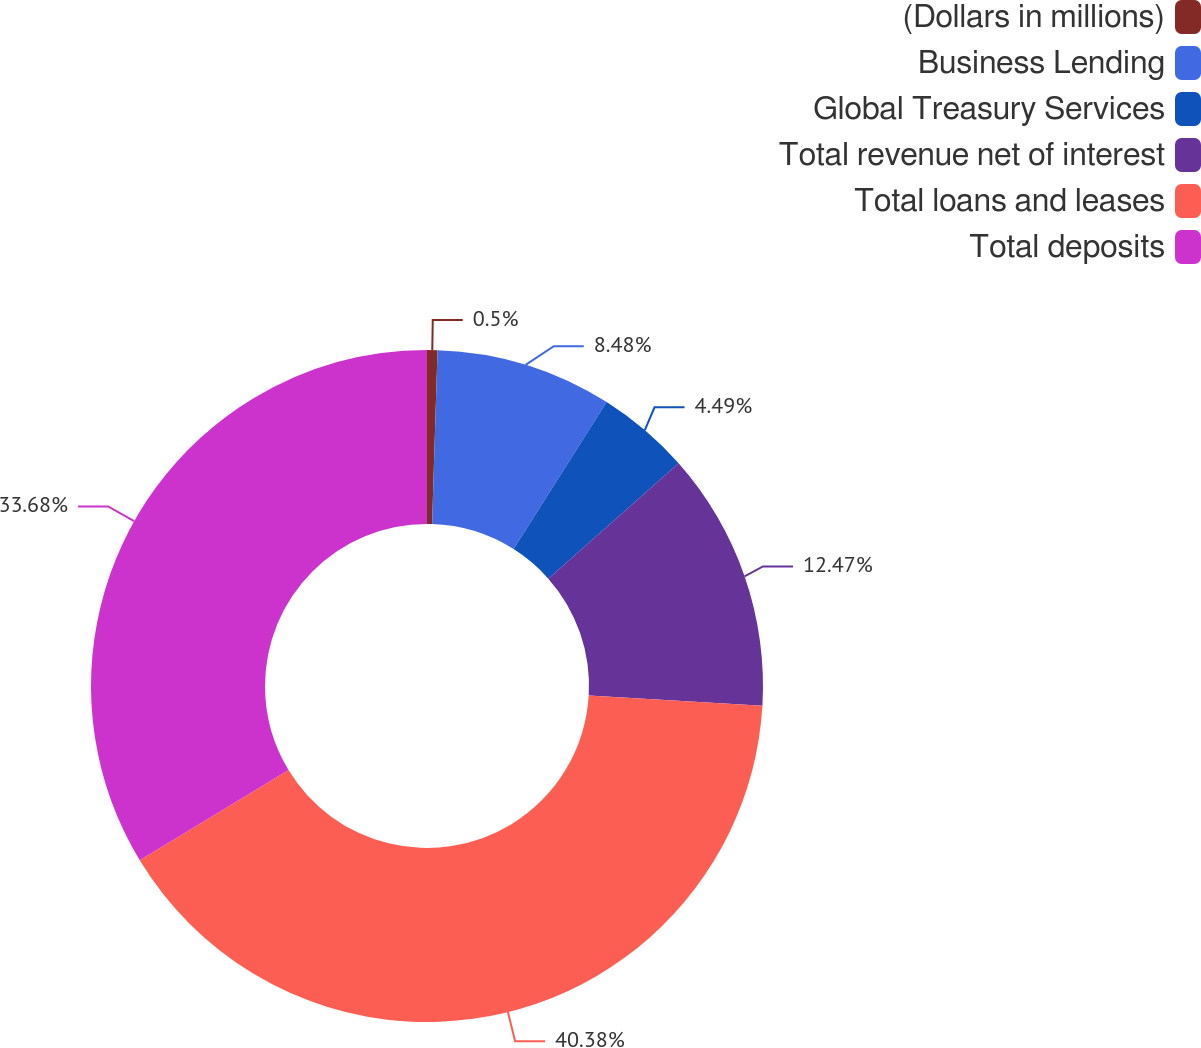Convert chart to OTSL. <chart><loc_0><loc_0><loc_500><loc_500><pie_chart><fcel>(Dollars in millions)<fcel>Business Lending<fcel>Global Treasury Services<fcel>Total revenue net of interest<fcel>Total loans and leases<fcel>Total deposits<nl><fcel>0.5%<fcel>8.48%<fcel>4.49%<fcel>12.47%<fcel>40.38%<fcel>33.68%<nl></chart> 